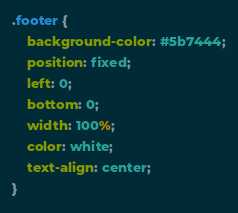<code> <loc_0><loc_0><loc_500><loc_500><_CSS_>.footer {
    background-color: #5b7444;
    position: fixed;
    left: 0;
    bottom: 0;
    width: 100%;
    color: white;
    text-align: center;
}</code> 